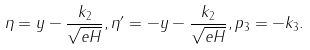Convert formula to latex. <formula><loc_0><loc_0><loc_500><loc_500>\eta = y - \frac { k _ { 2 } } { \sqrt { e H } } , \eta ^ { \prime } = - y - \frac { k _ { 2 } } { \sqrt { e H } } , p _ { 3 } = - k _ { 3 } .</formula> 